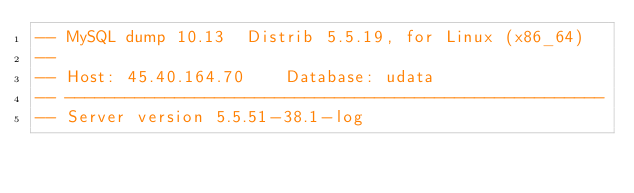<code> <loc_0><loc_0><loc_500><loc_500><_SQL_>-- MySQL dump 10.13  Distrib 5.5.19, for Linux (x86_64)
--
-- Host: 45.40.164.70    Database: udata
-- ------------------------------------------------------
-- Server version	5.5.51-38.1-log
</code> 